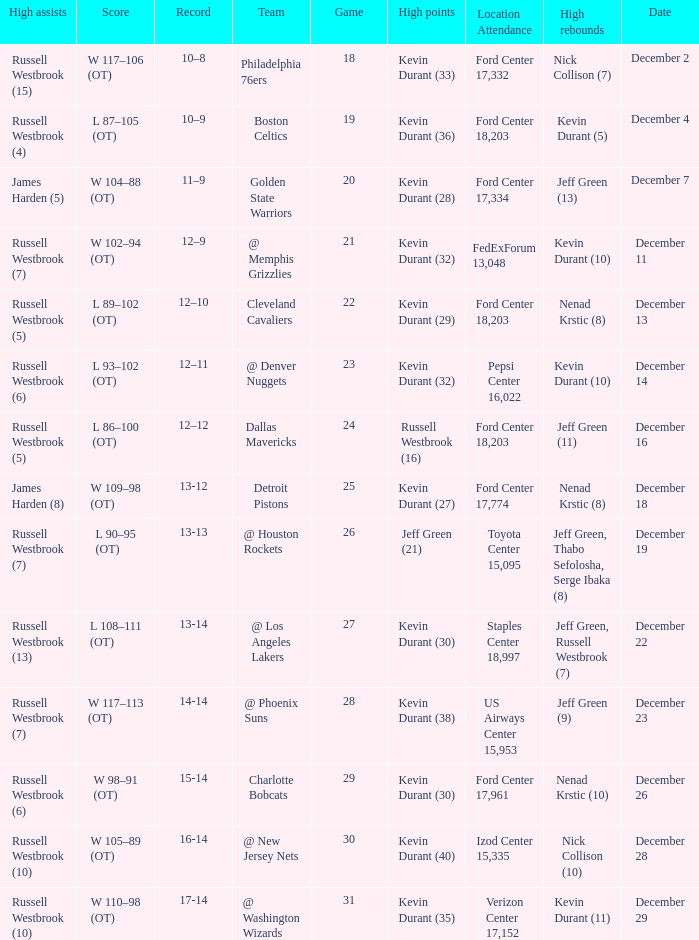Who has high points when verizon center 17,152 is location attendance? Kevin Durant (35). 